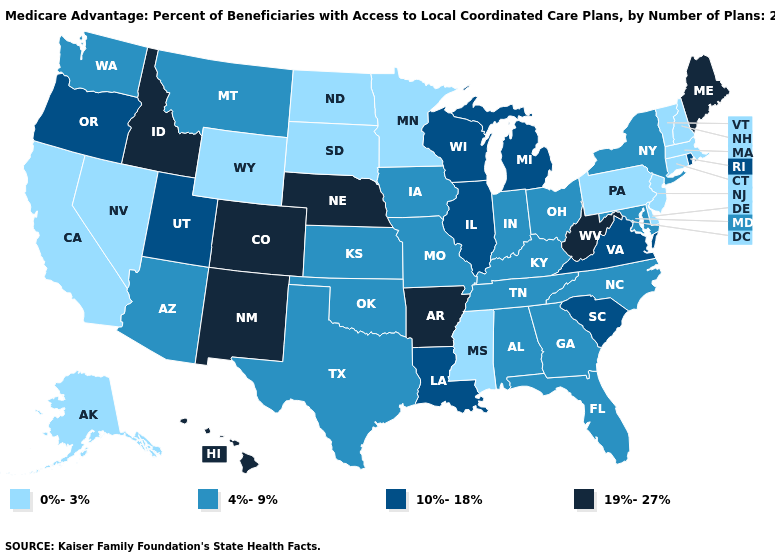Does Maine have the highest value in the Northeast?
Keep it brief. Yes. Does the first symbol in the legend represent the smallest category?
Answer briefly. Yes. Does Massachusetts have the highest value in the USA?
Keep it brief. No. Name the states that have a value in the range 0%-3%?
Write a very short answer. Alaska, California, Connecticut, Delaware, Massachusetts, Minnesota, Mississippi, North Dakota, New Hampshire, New Jersey, Nevada, Pennsylvania, South Dakota, Vermont, Wyoming. Name the states that have a value in the range 4%-9%?
Write a very short answer. Alabama, Arizona, Florida, Georgia, Iowa, Indiana, Kansas, Kentucky, Maryland, Missouri, Montana, North Carolina, New York, Ohio, Oklahoma, Tennessee, Texas, Washington. What is the lowest value in states that border New Mexico?
Concise answer only. 4%-9%. What is the highest value in states that border Oregon?
Write a very short answer. 19%-27%. Name the states that have a value in the range 0%-3%?
Concise answer only. Alaska, California, Connecticut, Delaware, Massachusetts, Minnesota, Mississippi, North Dakota, New Hampshire, New Jersey, Nevada, Pennsylvania, South Dakota, Vermont, Wyoming. Name the states that have a value in the range 4%-9%?
Concise answer only. Alabama, Arizona, Florida, Georgia, Iowa, Indiana, Kansas, Kentucky, Maryland, Missouri, Montana, North Carolina, New York, Ohio, Oklahoma, Tennessee, Texas, Washington. Name the states that have a value in the range 10%-18%?
Concise answer only. Illinois, Louisiana, Michigan, Oregon, Rhode Island, South Carolina, Utah, Virginia, Wisconsin. How many symbols are there in the legend?
Concise answer only. 4. What is the value of Michigan?
Short answer required. 10%-18%. Name the states that have a value in the range 4%-9%?
Be succinct. Alabama, Arizona, Florida, Georgia, Iowa, Indiana, Kansas, Kentucky, Maryland, Missouri, Montana, North Carolina, New York, Ohio, Oklahoma, Tennessee, Texas, Washington. What is the value of Idaho?
Quick response, please. 19%-27%. What is the value of New Mexico?
Be succinct. 19%-27%. 